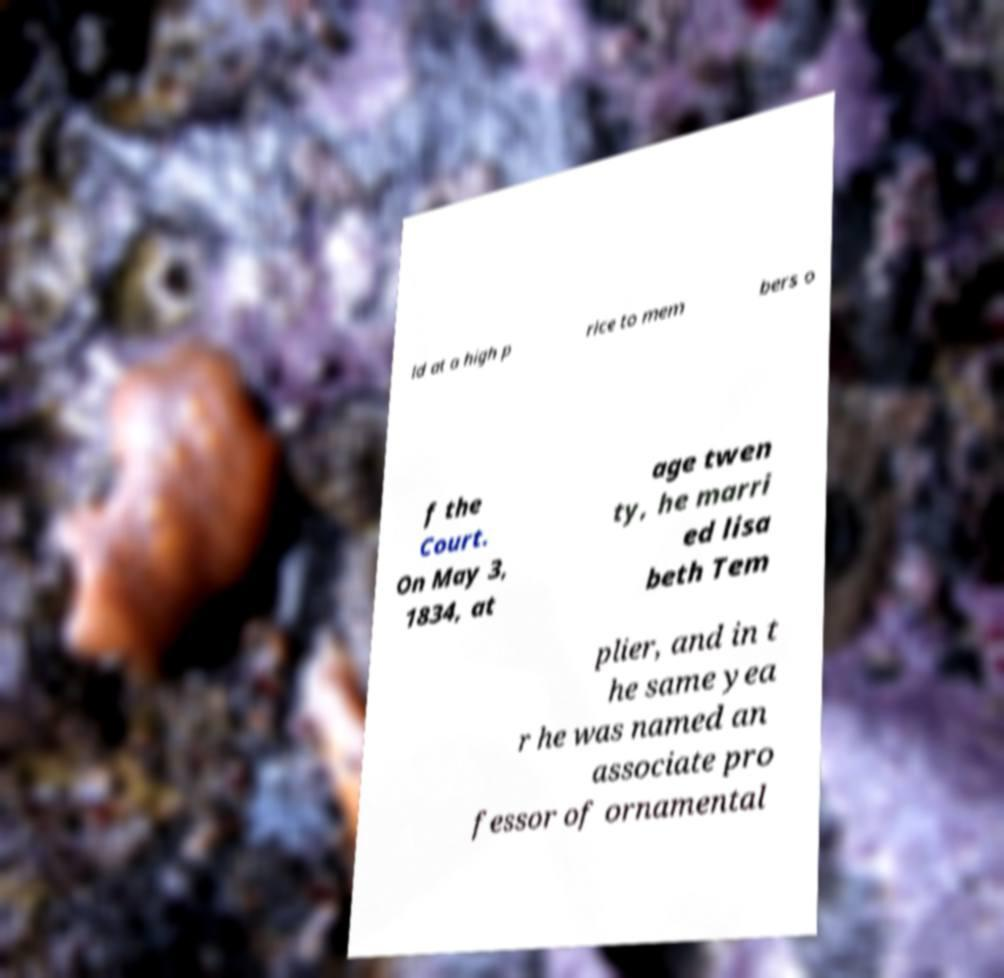Can you read and provide the text displayed in the image?This photo seems to have some interesting text. Can you extract and type it out for me? ld at a high p rice to mem bers o f the Court. On May 3, 1834, at age twen ty, he marri ed lisa beth Tem plier, and in t he same yea r he was named an associate pro fessor of ornamental 